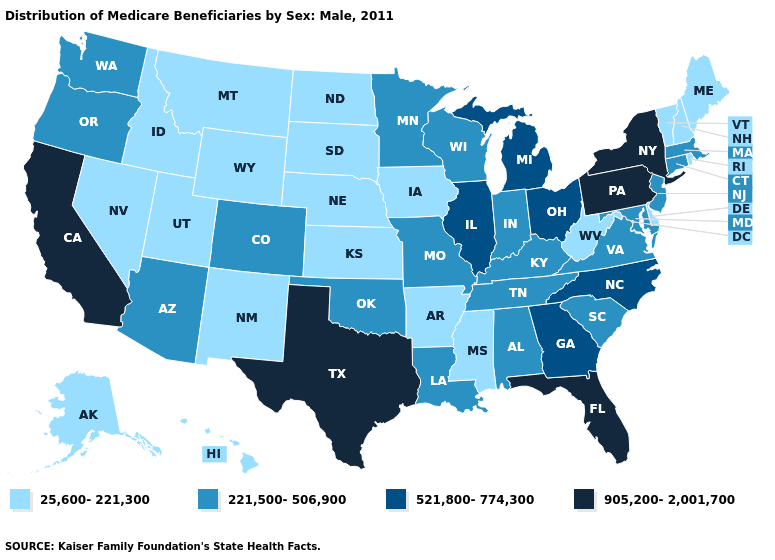Does Florida have the highest value in the USA?
Concise answer only. Yes. What is the lowest value in the USA?
Concise answer only. 25,600-221,300. Does Iowa have the lowest value in the MidWest?
Answer briefly. Yes. Does Pennsylvania have the same value as Texas?
Quick response, please. Yes. What is the value of Utah?
Give a very brief answer. 25,600-221,300. Name the states that have a value in the range 25,600-221,300?
Short answer required. Alaska, Arkansas, Delaware, Hawaii, Idaho, Iowa, Kansas, Maine, Mississippi, Montana, Nebraska, Nevada, New Hampshire, New Mexico, North Dakota, Rhode Island, South Dakota, Utah, Vermont, West Virginia, Wyoming. What is the value of Maryland?
Concise answer only. 221,500-506,900. What is the value of Indiana?
Be succinct. 221,500-506,900. Among the states that border Florida , which have the highest value?
Be succinct. Georgia. Does Nevada have the lowest value in the USA?
Give a very brief answer. Yes. Is the legend a continuous bar?
Give a very brief answer. No. Name the states that have a value in the range 521,800-774,300?
Quick response, please. Georgia, Illinois, Michigan, North Carolina, Ohio. What is the lowest value in the West?
Short answer required. 25,600-221,300. Name the states that have a value in the range 905,200-2,001,700?
Write a very short answer. California, Florida, New York, Pennsylvania, Texas. Does Wisconsin have the same value as Pennsylvania?
Concise answer only. No. 